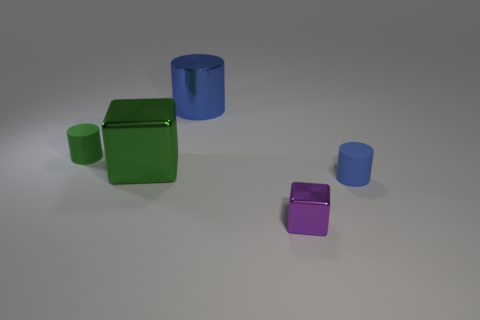What is the material of the thing that is the same color as the large metal cylinder?
Make the answer very short. Rubber. How many other objects are the same color as the big cylinder?
Provide a succinct answer. 1. What number of green rubber objects are there?
Ensure brevity in your answer.  1. What number of tiny cylinders are both right of the tiny purple metal block and on the left side of the metallic cylinder?
Provide a short and direct response. 0. What is the big green block made of?
Offer a terse response. Metal. Is there a large metal cube?
Your response must be concise. Yes. The small object that is in front of the tiny blue rubber cylinder is what color?
Offer a very short reply. Purple. What number of large blue shiny things are on the left side of the tiny matte object that is behind the tiny blue rubber thing right of the small purple shiny object?
Your answer should be very brief. 0. The cylinder that is both in front of the blue metal object and behind the large green shiny thing is made of what material?
Ensure brevity in your answer.  Rubber. Is the green cylinder made of the same material as the big object that is to the right of the big cube?
Your response must be concise. No. 